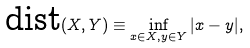<formula> <loc_0><loc_0><loc_500><loc_500>\text {dist} ( X , Y ) \equiv \inf _ { x \in X , y \in Y } | x - y | ,</formula> 